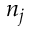<formula> <loc_0><loc_0><loc_500><loc_500>n _ { j }</formula> 